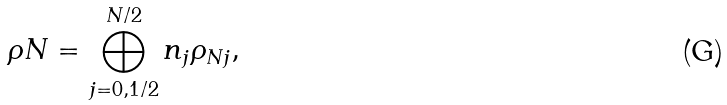Convert formula to latex. <formula><loc_0><loc_0><loc_500><loc_500>\rho N = \bigoplus _ { j = 0 , 1 / 2 } ^ { N / 2 } n _ { j } \rho _ { N j } ,</formula> 